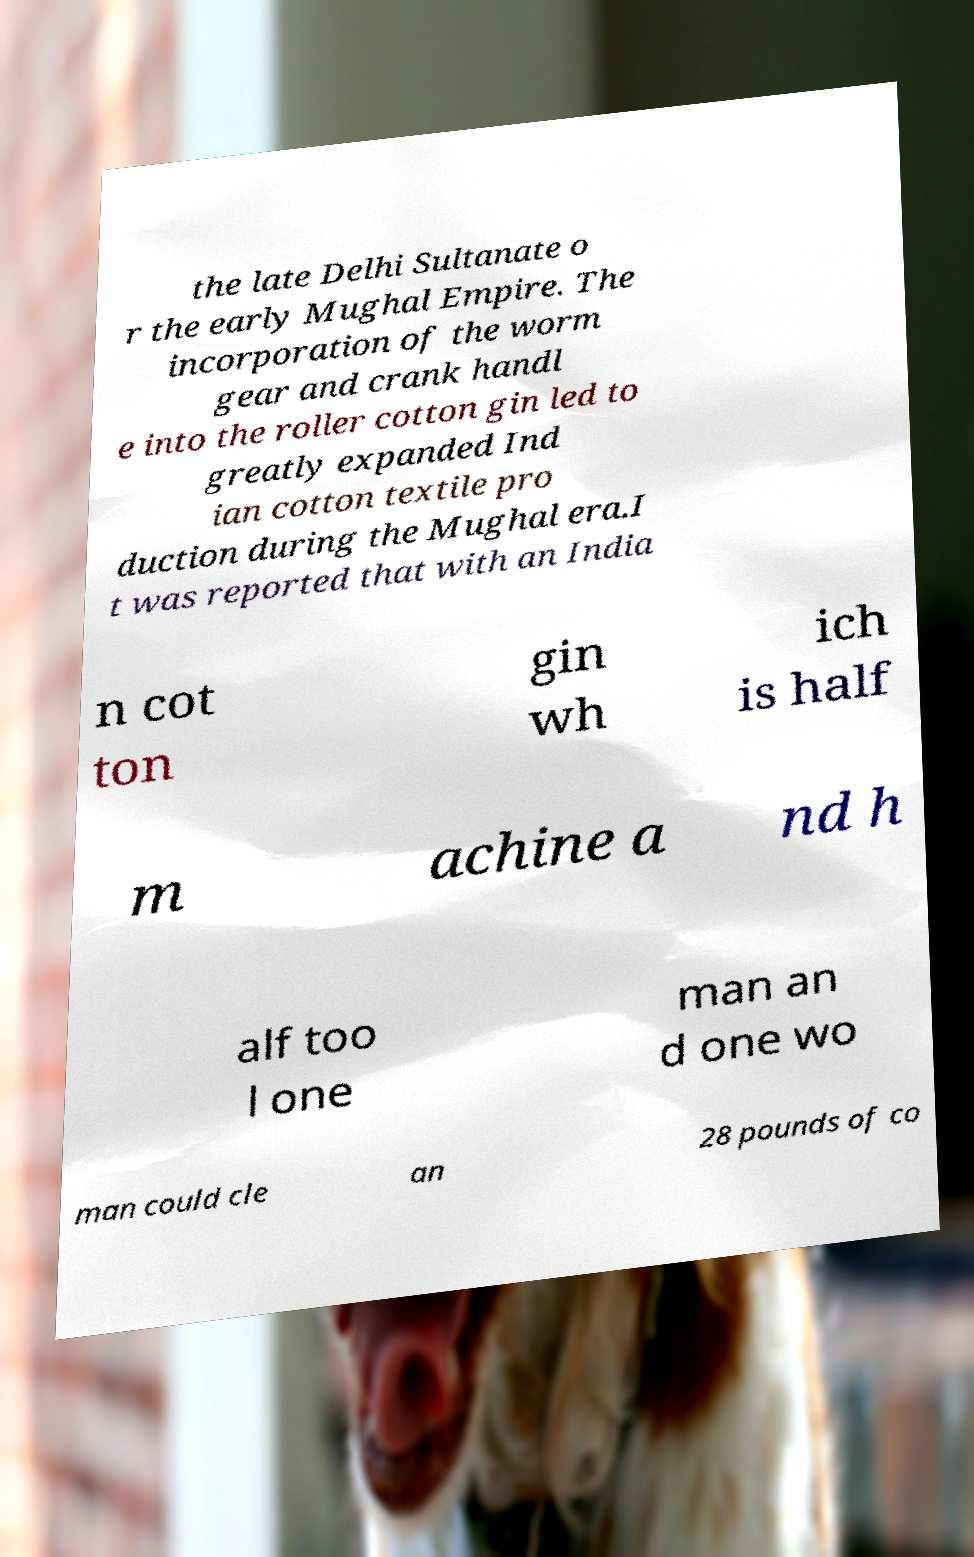What messages or text are displayed in this image? I need them in a readable, typed format. the late Delhi Sultanate o r the early Mughal Empire. The incorporation of the worm gear and crank handl e into the roller cotton gin led to greatly expanded Ind ian cotton textile pro duction during the Mughal era.I t was reported that with an India n cot ton gin wh ich is half m achine a nd h alf too l one man an d one wo man could cle an 28 pounds of co 